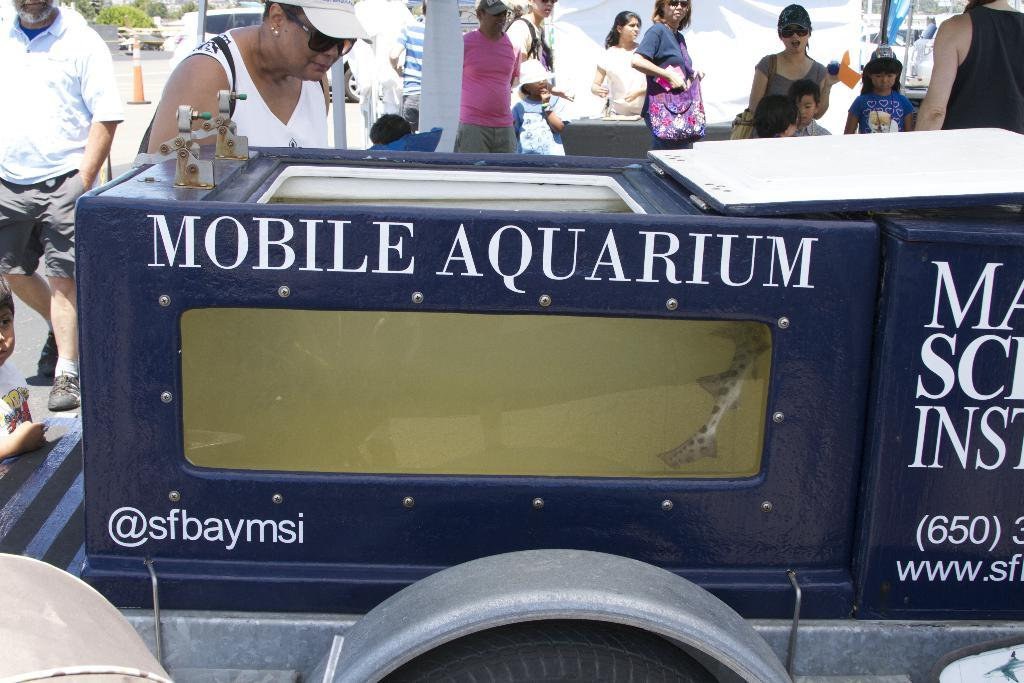What is the main subject of the image? There is a vehicle in the image. What else can be seen in the image besides the vehicle? There is an aquarium, a group of people standing on the road, a traffic cone, and trees in the background of the image. What type of wine is being served by the band in the image? There is no wine or band present in the image. 